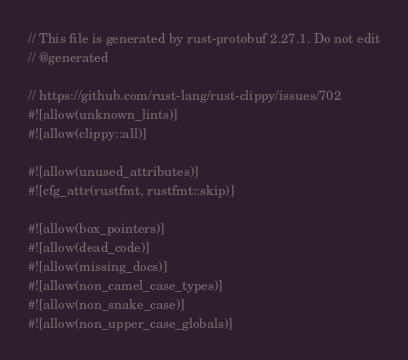<code> <loc_0><loc_0><loc_500><loc_500><_Rust_>// This file is generated by rust-protobuf 2.27.1. Do not edit
// @generated

// https://github.com/rust-lang/rust-clippy/issues/702
#![allow(unknown_lints)]
#![allow(clippy::all)]

#![allow(unused_attributes)]
#![cfg_attr(rustfmt, rustfmt::skip)]

#![allow(box_pointers)]
#![allow(dead_code)]
#![allow(missing_docs)]
#![allow(non_camel_case_types)]
#![allow(non_snake_case)]
#![allow(non_upper_case_globals)]</code> 